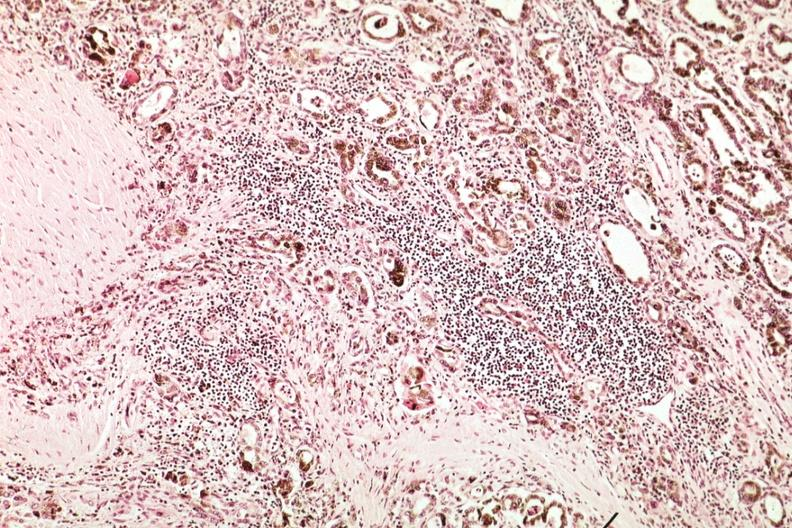s endocrine present?
Answer the question using a single word or phrase. Yes 